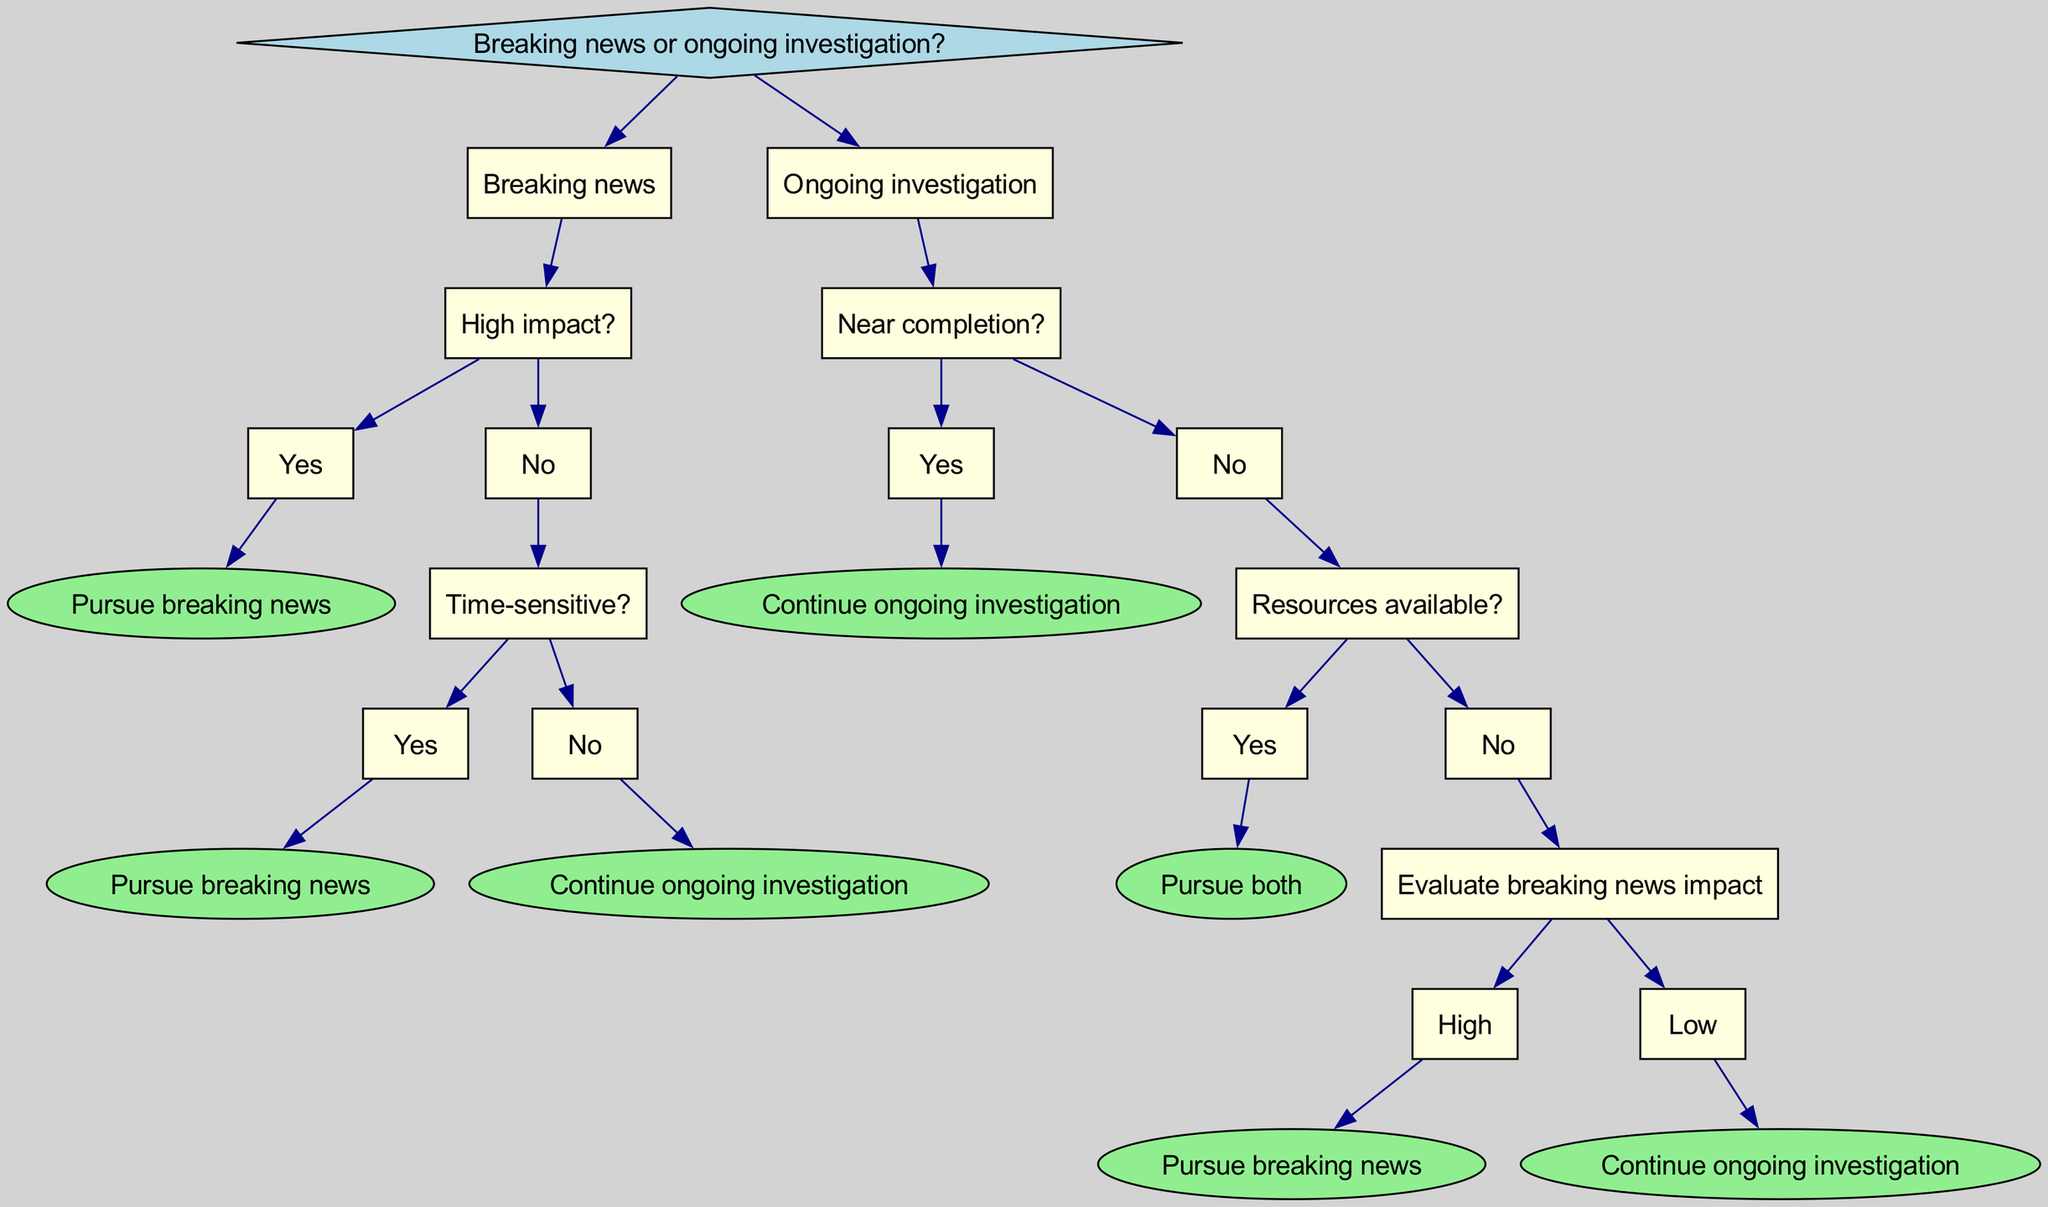What is the root node of the decision tree? The root node of the decision tree is the starting point and presents the initial decision to be made, which is whether to pursue breaking news or an ongoing investigation.
Answer: Breaking news or ongoing investigation? How many main branches are there from the root node? There are two main branches stemming directly from the root node: one for breaking news and one for ongoing investigation.
Answer: 2 What happens if the breaking news has a high impact? If the breaking news has a high impact, the decision tree indicates to pursue the breaking news immediately.
Answer: Pursue breaking news What condition leads to continuing the ongoing investigation instead of breaking news? Continuing the ongoing investigation occurs if the breaking news is not time-sensitive and does not have high impact. First, the tree checks whether the breaking news has high impact; if no, it further checks if it is time-sensitive, and if that is also no, then it opts to continue the ongoing investigation.
Answer: Continue ongoing investigation What determines whether to pursue both the ongoing investigation and breaking news? Pursuing both occurs if the ongoing investigation is not near completion, and there are sufficient resources available. The path to pursuing both involves evaluating both conditions, with the necessary conclusion on resource availability.
Answer: Pursue both What is the outcome if resources are not available for the ongoing investigation? If resources are not available, the decision tree assesses the impact of breaking news. If the impact is high, it suggests pursuing breaking news; if the impact is low, it indicates continuing the ongoing investigation.
Answer: Evaluate breaking news impact What is the leaf node that results from a low impact of breaking news after evaluating resources? If after evaluating resources and finding them unavailable, the breaking news impact is low, the leaf node indicates to continue the ongoing investigation.
Answer: Continue ongoing investigation Which node indicates that breaking news should definitely be pursued regardless of the other conditions? The node indicating that breaking news should definitely be pursued is "Pursue breaking news," which comes into effect if the impact is high or if it is time-sensitive.
Answer: Pursue breaking news 